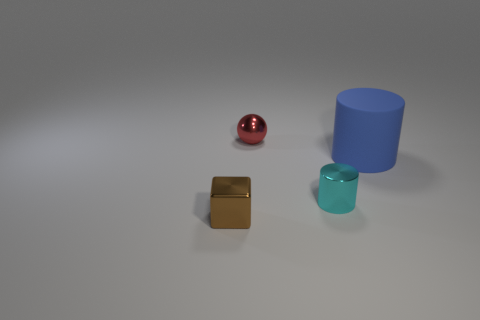Are there any tiny brown blocks that are to the right of the object that is behind the rubber cylinder?
Provide a short and direct response. No. Do the cyan thing and the cylinder that is to the right of the tiny cylinder have the same size?
Offer a terse response. No. Is there a blue matte cylinder that is on the right side of the shiny thing in front of the cylinder that is on the left side of the blue object?
Your answer should be compact. Yes. There is a object that is right of the metal cylinder; what is its material?
Keep it short and to the point. Rubber. Is the size of the cyan object the same as the red thing?
Offer a very short reply. Yes. What color is the small object that is both in front of the matte object and behind the metal cube?
Your response must be concise. Cyan. The cyan thing that is made of the same material as the brown block is what shape?
Make the answer very short. Cylinder. How many tiny metal things are both to the right of the brown metallic object and in front of the small red object?
Give a very brief answer. 1. Are there any big matte cylinders behind the tiny cube?
Offer a terse response. Yes. Is the shape of the thing that is on the right side of the tiny cylinder the same as the cyan object that is in front of the blue thing?
Your answer should be very brief. Yes. 